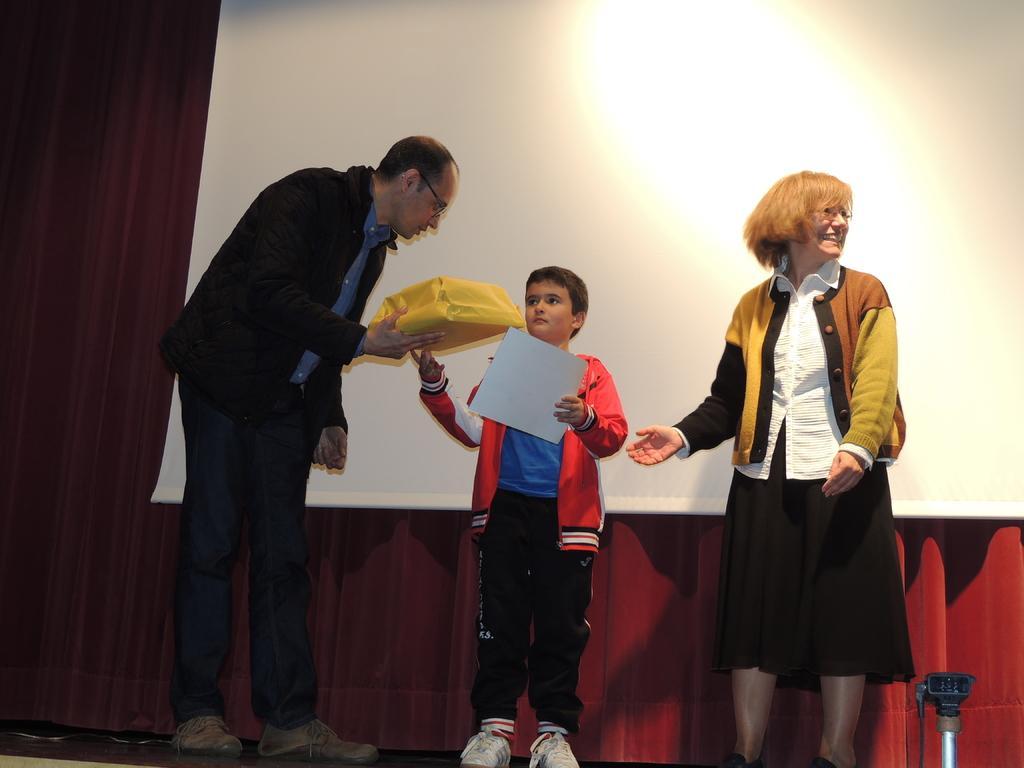Describe this image in one or two sentences. In this image there is a woman, man and a boy standing on a stage, a boy holding a paper in his hand and a man holding a box in his hand, in the background there is a red curtain and a white cloth. 